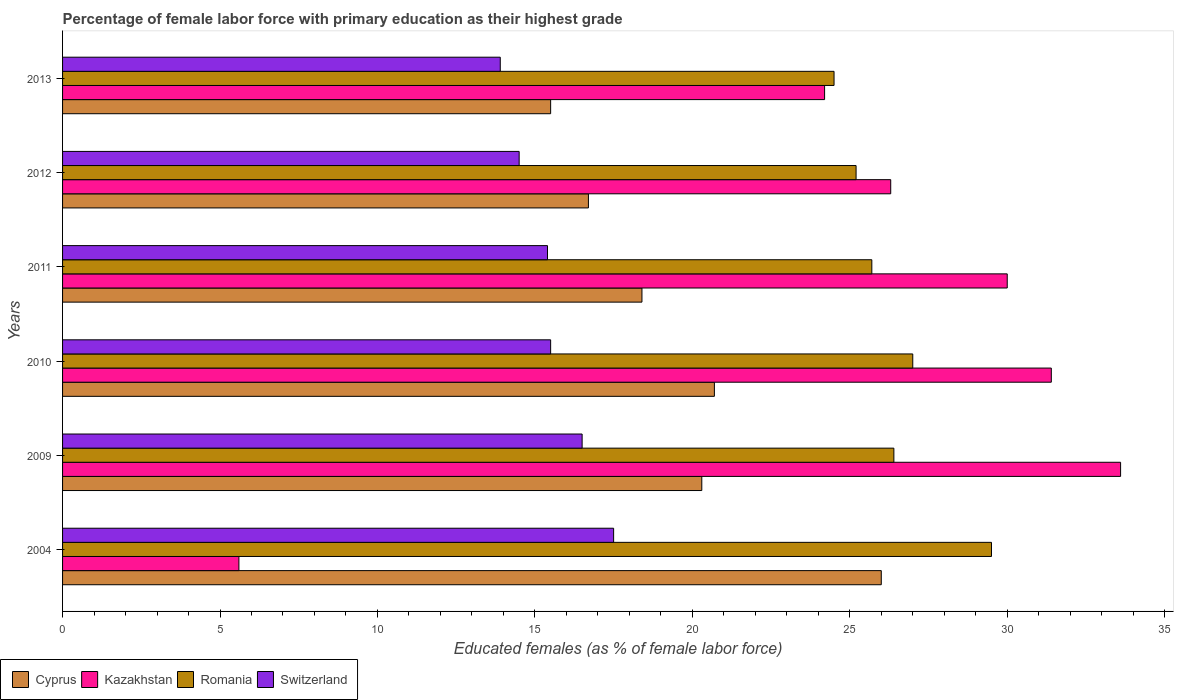How many different coloured bars are there?
Offer a terse response. 4. Are the number of bars on each tick of the Y-axis equal?
Your answer should be compact. Yes. How many bars are there on the 6th tick from the top?
Offer a terse response. 4. How many bars are there on the 5th tick from the bottom?
Offer a terse response. 4. What is the label of the 3rd group of bars from the top?
Provide a succinct answer. 2011. What is the percentage of female labor force with primary education in Romania in 2013?
Your response must be concise. 24.5. Across all years, what is the maximum percentage of female labor force with primary education in Cyprus?
Your response must be concise. 26. Across all years, what is the minimum percentage of female labor force with primary education in Switzerland?
Keep it short and to the point. 13.9. In which year was the percentage of female labor force with primary education in Cyprus maximum?
Your answer should be very brief. 2004. In which year was the percentage of female labor force with primary education in Romania minimum?
Make the answer very short. 2013. What is the total percentage of female labor force with primary education in Romania in the graph?
Give a very brief answer. 158.3. What is the difference between the percentage of female labor force with primary education in Romania in 2009 and that in 2010?
Ensure brevity in your answer.  -0.6. What is the difference between the percentage of female labor force with primary education in Switzerland in 2010 and the percentage of female labor force with primary education in Romania in 2012?
Offer a terse response. -9.7. What is the average percentage of female labor force with primary education in Romania per year?
Your answer should be compact. 26.38. In the year 2013, what is the difference between the percentage of female labor force with primary education in Cyprus and percentage of female labor force with primary education in Kazakhstan?
Offer a terse response. -8.7. What is the ratio of the percentage of female labor force with primary education in Romania in 2004 to that in 2010?
Ensure brevity in your answer.  1.09. Is the percentage of female labor force with primary education in Cyprus in 2011 less than that in 2013?
Ensure brevity in your answer.  No. Is the difference between the percentage of female labor force with primary education in Cyprus in 2009 and 2012 greater than the difference between the percentage of female labor force with primary education in Kazakhstan in 2009 and 2012?
Your answer should be compact. No. Is the sum of the percentage of female labor force with primary education in Switzerland in 2011 and 2012 greater than the maximum percentage of female labor force with primary education in Kazakhstan across all years?
Your response must be concise. No. Is it the case that in every year, the sum of the percentage of female labor force with primary education in Romania and percentage of female labor force with primary education in Kazakhstan is greater than the sum of percentage of female labor force with primary education in Cyprus and percentage of female labor force with primary education in Switzerland?
Offer a very short reply. No. What does the 1st bar from the top in 2009 represents?
Provide a succinct answer. Switzerland. What does the 3rd bar from the bottom in 2011 represents?
Keep it short and to the point. Romania. Are all the bars in the graph horizontal?
Your response must be concise. Yes. How many years are there in the graph?
Your response must be concise. 6. Are the values on the major ticks of X-axis written in scientific E-notation?
Make the answer very short. No. Does the graph contain any zero values?
Keep it short and to the point. No. Does the graph contain grids?
Your answer should be compact. No. Where does the legend appear in the graph?
Keep it short and to the point. Bottom left. What is the title of the graph?
Provide a short and direct response. Percentage of female labor force with primary education as their highest grade. What is the label or title of the X-axis?
Provide a short and direct response. Educated females (as % of female labor force). What is the label or title of the Y-axis?
Give a very brief answer. Years. What is the Educated females (as % of female labor force) in Cyprus in 2004?
Provide a succinct answer. 26. What is the Educated females (as % of female labor force) in Kazakhstan in 2004?
Offer a very short reply. 5.6. What is the Educated females (as % of female labor force) of Romania in 2004?
Provide a succinct answer. 29.5. What is the Educated females (as % of female labor force) of Cyprus in 2009?
Your response must be concise. 20.3. What is the Educated females (as % of female labor force) of Kazakhstan in 2009?
Offer a terse response. 33.6. What is the Educated females (as % of female labor force) in Romania in 2009?
Your response must be concise. 26.4. What is the Educated females (as % of female labor force) of Switzerland in 2009?
Offer a very short reply. 16.5. What is the Educated females (as % of female labor force) of Cyprus in 2010?
Offer a terse response. 20.7. What is the Educated females (as % of female labor force) in Kazakhstan in 2010?
Make the answer very short. 31.4. What is the Educated females (as % of female labor force) of Switzerland in 2010?
Keep it short and to the point. 15.5. What is the Educated females (as % of female labor force) in Cyprus in 2011?
Offer a terse response. 18.4. What is the Educated females (as % of female labor force) in Romania in 2011?
Offer a very short reply. 25.7. What is the Educated females (as % of female labor force) of Switzerland in 2011?
Ensure brevity in your answer.  15.4. What is the Educated females (as % of female labor force) in Cyprus in 2012?
Give a very brief answer. 16.7. What is the Educated females (as % of female labor force) of Kazakhstan in 2012?
Your response must be concise. 26.3. What is the Educated females (as % of female labor force) of Romania in 2012?
Give a very brief answer. 25.2. What is the Educated females (as % of female labor force) in Kazakhstan in 2013?
Your answer should be very brief. 24.2. What is the Educated females (as % of female labor force) in Romania in 2013?
Your answer should be compact. 24.5. What is the Educated females (as % of female labor force) in Switzerland in 2013?
Your answer should be compact. 13.9. Across all years, what is the maximum Educated females (as % of female labor force) in Cyprus?
Give a very brief answer. 26. Across all years, what is the maximum Educated females (as % of female labor force) in Kazakhstan?
Keep it short and to the point. 33.6. Across all years, what is the maximum Educated females (as % of female labor force) of Romania?
Provide a succinct answer. 29.5. Across all years, what is the maximum Educated females (as % of female labor force) of Switzerland?
Make the answer very short. 17.5. Across all years, what is the minimum Educated females (as % of female labor force) in Kazakhstan?
Your answer should be very brief. 5.6. Across all years, what is the minimum Educated females (as % of female labor force) of Romania?
Offer a very short reply. 24.5. Across all years, what is the minimum Educated females (as % of female labor force) in Switzerland?
Keep it short and to the point. 13.9. What is the total Educated females (as % of female labor force) of Cyprus in the graph?
Ensure brevity in your answer.  117.6. What is the total Educated females (as % of female labor force) of Kazakhstan in the graph?
Keep it short and to the point. 151.1. What is the total Educated females (as % of female labor force) in Romania in the graph?
Keep it short and to the point. 158.3. What is the total Educated females (as % of female labor force) of Switzerland in the graph?
Keep it short and to the point. 93.3. What is the difference between the Educated females (as % of female labor force) of Cyprus in 2004 and that in 2009?
Offer a terse response. 5.7. What is the difference between the Educated females (as % of female labor force) of Kazakhstan in 2004 and that in 2009?
Provide a short and direct response. -28. What is the difference between the Educated females (as % of female labor force) of Cyprus in 2004 and that in 2010?
Offer a terse response. 5.3. What is the difference between the Educated females (as % of female labor force) in Kazakhstan in 2004 and that in 2010?
Give a very brief answer. -25.8. What is the difference between the Educated females (as % of female labor force) in Switzerland in 2004 and that in 2010?
Make the answer very short. 2. What is the difference between the Educated females (as % of female labor force) of Kazakhstan in 2004 and that in 2011?
Your response must be concise. -24.4. What is the difference between the Educated females (as % of female labor force) in Kazakhstan in 2004 and that in 2012?
Keep it short and to the point. -20.7. What is the difference between the Educated females (as % of female labor force) in Switzerland in 2004 and that in 2012?
Keep it short and to the point. 3. What is the difference between the Educated females (as % of female labor force) in Cyprus in 2004 and that in 2013?
Make the answer very short. 10.5. What is the difference between the Educated females (as % of female labor force) in Kazakhstan in 2004 and that in 2013?
Offer a very short reply. -18.6. What is the difference between the Educated females (as % of female labor force) in Cyprus in 2009 and that in 2010?
Your answer should be compact. -0.4. What is the difference between the Educated females (as % of female labor force) in Romania in 2009 and that in 2010?
Ensure brevity in your answer.  -0.6. What is the difference between the Educated females (as % of female labor force) of Cyprus in 2009 and that in 2011?
Ensure brevity in your answer.  1.9. What is the difference between the Educated females (as % of female labor force) in Kazakhstan in 2009 and that in 2011?
Your answer should be compact. 3.6. What is the difference between the Educated females (as % of female labor force) in Romania in 2009 and that in 2011?
Keep it short and to the point. 0.7. What is the difference between the Educated females (as % of female labor force) of Cyprus in 2009 and that in 2012?
Provide a succinct answer. 3.6. What is the difference between the Educated females (as % of female labor force) in Romania in 2009 and that in 2012?
Your answer should be very brief. 1.2. What is the difference between the Educated females (as % of female labor force) in Romania in 2009 and that in 2013?
Your answer should be very brief. 1.9. What is the difference between the Educated females (as % of female labor force) in Switzerland in 2009 and that in 2013?
Provide a short and direct response. 2.6. What is the difference between the Educated females (as % of female labor force) of Cyprus in 2010 and that in 2011?
Your response must be concise. 2.3. What is the difference between the Educated females (as % of female labor force) of Kazakhstan in 2010 and that in 2011?
Your response must be concise. 1.4. What is the difference between the Educated females (as % of female labor force) of Romania in 2010 and that in 2012?
Your answer should be compact. 1.8. What is the difference between the Educated females (as % of female labor force) of Switzerland in 2010 and that in 2012?
Keep it short and to the point. 1. What is the difference between the Educated females (as % of female labor force) in Cyprus in 2010 and that in 2013?
Give a very brief answer. 5.2. What is the difference between the Educated females (as % of female labor force) of Romania in 2010 and that in 2013?
Provide a short and direct response. 2.5. What is the difference between the Educated females (as % of female labor force) in Switzerland in 2010 and that in 2013?
Your response must be concise. 1.6. What is the difference between the Educated females (as % of female labor force) in Cyprus in 2011 and that in 2012?
Your answer should be compact. 1.7. What is the difference between the Educated females (as % of female labor force) of Kazakhstan in 2011 and that in 2012?
Your response must be concise. 3.7. What is the difference between the Educated females (as % of female labor force) of Cyprus in 2011 and that in 2013?
Offer a very short reply. 2.9. What is the difference between the Educated females (as % of female labor force) in Cyprus in 2004 and the Educated females (as % of female labor force) in Kazakhstan in 2009?
Provide a short and direct response. -7.6. What is the difference between the Educated females (as % of female labor force) in Cyprus in 2004 and the Educated females (as % of female labor force) in Romania in 2009?
Provide a succinct answer. -0.4. What is the difference between the Educated females (as % of female labor force) of Kazakhstan in 2004 and the Educated females (as % of female labor force) of Romania in 2009?
Your response must be concise. -20.8. What is the difference between the Educated females (as % of female labor force) in Romania in 2004 and the Educated females (as % of female labor force) in Switzerland in 2009?
Provide a short and direct response. 13. What is the difference between the Educated females (as % of female labor force) of Cyprus in 2004 and the Educated females (as % of female labor force) of Romania in 2010?
Make the answer very short. -1. What is the difference between the Educated females (as % of female labor force) in Kazakhstan in 2004 and the Educated females (as % of female labor force) in Romania in 2010?
Your response must be concise. -21.4. What is the difference between the Educated females (as % of female labor force) in Romania in 2004 and the Educated females (as % of female labor force) in Switzerland in 2010?
Offer a very short reply. 14. What is the difference between the Educated females (as % of female labor force) of Cyprus in 2004 and the Educated females (as % of female labor force) of Kazakhstan in 2011?
Offer a very short reply. -4. What is the difference between the Educated females (as % of female labor force) in Cyprus in 2004 and the Educated females (as % of female labor force) in Switzerland in 2011?
Your answer should be very brief. 10.6. What is the difference between the Educated females (as % of female labor force) of Kazakhstan in 2004 and the Educated females (as % of female labor force) of Romania in 2011?
Your answer should be compact. -20.1. What is the difference between the Educated females (as % of female labor force) of Kazakhstan in 2004 and the Educated females (as % of female labor force) of Switzerland in 2011?
Ensure brevity in your answer.  -9.8. What is the difference between the Educated females (as % of female labor force) in Romania in 2004 and the Educated females (as % of female labor force) in Switzerland in 2011?
Offer a very short reply. 14.1. What is the difference between the Educated females (as % of female labor force) of Kazakhstan in 2004 and the Educated females (as % of female labor force) of Romania in 2012?
Your response must be concise. -19.6. What is the difference between the Educated females (as % of female labor force) in Romania in 2004 and the Educated females (as % of female labor force) in Switzerland in 2012?
Keep it short and to the point. 15. What is the difference between the Educated females (as % of female labor force) of Cyprus in 2004 and the Educated females (as % of female labor force) of Switzerland in 2013?
Offer a very short reply. 12.1. What is the difference between the Educated females (as % of female labor force) of Kazakhstan in 2004 and the Educated females (as % of female labor force) of Romania in 2013?
Provide a short and direct response. -18.9. What is the difference between the Educated females (as % of female labor force) of Kazakhstan in 2004 and the Educated females (as % of female labor force) of Switzerland in 2013?
Provide a short and direct response. -8.3. What is the difference between the Educated females (as % of female labor force) of Cyprus in 2009 and the Educated females (as % of female labor force) of Switzerland in 2010?
Your answer should be very brief. 4.8. What is the difference between the Educated females (as % of female labor force) of Kazakhstan in 2009 and the Educated females (as % of female labor force) of Switzerland in 2010?
Your answer should be very brief. 18.1. What is the difference between the Educated females (as % of female labor force) in Cyprus in 2009 and the Educated females (as % of female labor force) in Kazakhstan in 2011?
Offer a terse response. -9.7. What is the difference between the Educated females (as % of female labor force) in Cyprus in 2009 and the Educated females (as % of female labor force) in Romania in 2011?
Offer a very short reply. -5.4. What is the difference between the Educated females (as % of female labor force) of Cyprus in 2009 and the Educated females (as % of female labor force) of Switzerland in 2011?
Your answer should be compact. 4.9. What is the difference between the Educated females (as % of female labor force) in Kazakhstan in 2009 and the Educated females (as % of female labor force) in Romania in 2011?
Offer a very short reply. 7.9. What is the difference between the Educated females (as % of female labor force) of Kazakhstan in 2009 and the Educated females (as % of female labor force) of Switzerland in 2011?
Your answer should be very brief. 18.2. What is the difference between the Educated females (as % of female labor force) of Kazakhstan in 2009 and the Educated females (as % of female labor force) of Romania in 2012?
Ensure brevity in your answer.  8.4. What is the difference between the Educated females (as % of female labor force) in Kazakhstan in 2009 and the Educated females (as % of female labor force) in Switzerland in 2012?
Give a very brief answer. 19.1. What is the difference between the Educated females (as % of female labor force) in Romania in 2009 and the Educated females (as % of female labor force) in Switzerland in 2012?
Your answer should be compact. 11.9. What is the difference between the Educated females (as % of female labor force) in Cyprus in 2009 and the Educated females (as % of female labor force) in Kazakhstan in 2013?
Make the answer very short. -3.9. What is the difference between the Educated females (as % of female labor force) of Cyprus in 2009 and the Educated females (as % of female labor force) of Romania in 2013?
Provide a succinct answer. -4.2. What is the difference between the Educated females (as % of female labor force) of Kazakhstan in 2009 and the Educated females (as % of female labor force) of Switzerland in 2013?
Your response must be concise. 19.7. What is the difference between the Educated females (as % of female labor force) in Romania in 2009 and the Educated females (as % of female labor force) in Switzerland in 2013?
Provide a short and direct response. 12.5. What is the difference between the Educated females (as % of female labor force) of Cyprus in 2010 and the Educated females (as % of female labor force) of Switzerland in 2011?
Provide a succinct answer. 5.3. What is the difference between the Educated females (as % of female labor force) of Kazakhstan in 2010 and the Educated females (as % of female labor force) of Switzerland in 2011?
Give a very brief answer. 16. What is the difference between the Educated females (as % of female labor force) in Cyprus in 2010 and the Educated females (as % of female labor force) in Kazakhstan in 2012?
Ensure brevity in your answer.  -5.6. What is the difference between the Educated females (as % of female labor force) of Cyprus in 2010 and the Educated females (as % of female labor force) of Romania in 2012?
Provide a short and direct response. -4.5. What is the difference between the Educated females (as % of female labor force) of Kazakhstan in 2010 and the Educated females (as % of female labor force) of Romania in 2012?
Give a very brief answer. 6.2. What is the difference between the Educated females (as % of female labor force) in Kazakhstan in 2010 and the Educated females (as % of female labor force) in Switzerland in 2012?
Your answer should be compact. 16.9. What is the difference between the Educated females (as % of female labor force) of Cyprus in 2010 and the Educated females (as % of female labor force) of Kazakhstan in 2013?
Keep it short and to the point. -3.5. What is the difference between the Educated females (as % of female labor force) in Cyprus in 2010 and the Educated females (as % of female labor force) in Switzerland in 2013?
Provide a short and direct response. 6.8. What is the difference between the Educated females (as % of female labor force) in Kazakhstan in 2010 and the Educated females (as % of female labor force) in Switzerland in 2013?
Offer a terse response. 17.5. What is the difference between the Educated females (as % of female labor force) in Romania in 2010 and the Educated females (as % of female labor force) in Switzerland in 2013?
Keep it short and to the point. 13.1. What is the difference between the Educated females (as % of female labor force) of Cyprus in 2011 and the Educated females (as % of female labor force) of Switzerland in 2012?
Your answer should be very brief. 3.9. What is the difference between the Educated females (as % of female labor force) of Kazakhstan in 2011 and the Educated females (as % of female labor force) of Romania in 2012?
Your answer should be compact. 4.8. What is the difference between the Educated females (as % of female labor force) in Cyprus in 2011 and the Educated females (as % of female labor force) in Kazakhstan in 2013?
Your answer should be very brief. -5.8. What is the difference between the Educated females (as % of female labor force) in Cyprus in 2011 and the Educated females (as % of female labor force) in Romania in 2013?
Ensure brevity in your answer.  -6.1. What is the difference between the Educated females (as % of female labor force) of Cyprus in 2011 and the Educated females (as % of female labor force) of Switzerland in 2013?
Give a very brief answer. 4.5. What is the difference between the Educated females (as % of female labor force) in Kazakhstan in 2011 and the Educated females (as % of female labor force) in Romania in 2013?
Offer a terse response. 5.5. What is the difference between the Educated females (as % of female labor force) in Kazakhstan in 2011 and the Educated females (as % of female labor force) in Switzerland in 2013?
Your answer should be very brief. 16.1. What is the difference between the Educated females (as % of female labor force) of Cyprus in 2012 and the Educated females (as % of female labor force) of Kazakhstan in 2013?
Make the answer very short. -7.5. What is the difference between the Educated females (as % of female labor force) in Cyprus in 2012 and the Educated females (as % of female labor force) in Switzerland in 2013?
Provide a short and direct response. 2.8. What is the difference between the Educated females (as % of female labor force) in Kazakhstan in 2012 and the Educated females (as % of female labor force) in Switzerland in 2013?
Make the answer very short. 12.4. What is the average Educated females (as % of female labor force) of Cyprus per year?
Your answer should be compact. 19.6. What is the average Educated females (as % of female labor force) of Kazakhstan per year?
Your answer should be very brief. 25.18. What is the average Educated females (as % of female labor force) of Romania per year?
Offer a terse response. 26.38. What is the average Educated females (as % of female labor force) in Switzerland per year?
Keep it short and to the point. 15.55. In the year 2004, what is the difference between the Educated females (as % of female labor force) of Cyprus and Educated females (as % of female labor force) of Kazakhstan?
Keep it short and to the point. 20.4. In the year 2004, what is the difference between the Educated females (as % of female labor force) of Cyprus and Educated females (as % of female labor force) of Romania?
Ensure brevity in your answer.  -3.5. In the year 2004, what is the difference between the Educated females (as % of female labor force) of Kazakhstan and Educated females (as % of female labor force) of Romania?
Ensure brevity in your answer.  -23.9. In the year 2004, what is the difference between the Educated females (as % of female labor force) in Kazakhstan and Educated females (as % of female labor force) in Switzerland?
Offer a terse response. -11.9. In the year 2004, what is the difference between the Educated females (as % of female labor force) of Romania and Educated females (as % of female labor force) of Switzerland?
Your answer should be very brief. 12. In the year 2009, what is the difference between the Educated females (as % of female labor force) of Cyprus and Educated females (as % of female labor force) of Kazakhstan?
Make the answer very short. -13.3. In the year 2009, what is the difference between the Educated females (as % of female labor force) in Cyprus and Educated females (as % of female labor force) in Romania?
Offer a very short reply. -6.1. In the year 2009, what is the difference between the Educated females (as % of female labor force) in Cyprus and Educated females (as % of female labor force) in Switzerland?
Your answer should be very brief. 3.8. In the year 2009, what is the difference between the Educated females (as % of female labor force) in Kazakhstan and Educated females (as % of female labor force) in Romania?
Provide a succinct answer. 7.2. In the year 2009, what is the difference between the Educated females (as % of female labor force) in Kazakhstan and Educated females (as % of female labor force) in Switzerland?
Give a very brief answer. 17.1. In the year 2010, what is the difference between the Educated females (as % of female labor force) of Kazakhstan and Educated females (as % of female labor force) of Romania?
Make the answer very short. 4.4. In the year 2011, what is the difference between the Educated females (as % of female labor force) of Cyprus and Educated females (as % of female labor force) of Kazakhstan?
Your answer should be very brief. -11.6. In the year 2011, what is the difference between the Educated females (as % of female labor force) in Cyprus and Educated females (as % of female labor force) in Romania?
Make the answer very short. -7.3. In the year 2011, what is the difference between the Educated females (as % of female labor force) in Cyprus and Educated females (as % of female labor force) in Switzerland?
Offer a terse response. 3. In the year 2011, what is the difference between the Educated females (as % of female labor force) in Kazakhstan and Educated females (as % of female labor force) in Switzerland?
Provide a short and direct response. 14.6. In the year 2011, what is the difference between the Educated females (as % of female labor force) of Romania and Educated females (as % of female labor force) of Switzerland?
Your response must be concise. 10.3. In the year 2012, what is the difference between the Educated females (as % of female labor force) of Cyprus and Educated females (as % of female labor force) of Kazakhstan?
Give a very brief answer. -9.6. In the year 2012, what is the difference between the Educated females (as % of female labor force) in Kazakhstan and Educated females (as % of female labor force) in Romania?
Provide a short and direct response. 1.1. In the year 2012, what is the difference between the Educated females (as % of female labor force) in Kazakhstan and Educated females (as % of female labor force) in Switzerland?
Provide a short and direct response. 11.8. In the year 2012, what is the difference between the Educated females (as % of female labor force) of Romania and Educated females (as % of female labor force) of Switzerland?
Ensure brevity in your answer.  10.7. In the year 2013, what is the difference between the Educated females (as % of female labor force) in Cyprus and Educated females (as % of female labor force) in Kazakhstan?
Provide a succinct answer. -8.7. In the year 2013, what is the difference between the Educated females (as % of female labor force) of Kazakhstan and Educated females (as % of female labor force) of Romania?
Make the answer very short. -0.3. In the year 2013, what is the difference between the Educated females (as % of female labor force) in Kazakhstan and Educated females (as % of female labor force) in Switzerland?
Offer a very short reply. 10.3. In the year 2013, what is the difference between the Educated females (as % of female labor force) of Romania and Educated females (as % of female labor force) of Switzerland?
Your response must be concise. 10.6. What is the ratio of the Educated females (as % of female labor force) of Cyprus in 2004 to that in 2009?
Keep it short and to the point. 1.28. What is the ratio of the Educated females (as % of female labor force) of Romania in 2004 to that in 2009?
Your answer should be compact. 1.12. What is the ratio of the Educated females (as % of female labor force) in Switzerland in 2004 to that in 2009?
Ensure brevity in your answer.  1.06. What is the ratio of the Educated females (as % of female labor force) in Cyprus in 2004 to that in 2010?
Offer a very short reply. 1.26. What is the ratio of the Educated females (as % of female labor force) in Kazakhstan in 2004 to that in 2010?
Your response must be concise. 0.18. What is the ratio of the Educated females (as % of female labor force) in Romania in 2004 to that in 2010?
Give a very brief answer. 1.09. What is the ratio of the Educated females (as % of female labor force) in Switzerland in 2004 to that in 2010?
Make the answer very short. 1.13. What is the ratio of the Educated females (as % of female labor force) of Cyprus in 2004 to that in 2011?
Ensure brevity in your answer.  1.41. What is the ratio of the Educated females (as % of female labor force) of Kazakhstan in 2004 to that in 2011?
Make the answer very short. 0.19. What is the ratio of the Educated females (as % of female labor force) of Romania in 2004 to that in 2011?
Your response must be concise. 1.15. What is the ratio of the Educated females (as % of female labor force) in Switzerland in 2004 to that in 2011?
Keep it short and to the point. 1.14. What is the ratio of the Educated females (as % of female labor force) in Cyprus in 2004 to that in 2012?
Provide a succinct answer. 1.56. What is the ratio of the Educated females (as % of female labor force) in Kazakhstan in 2004 to that in 2012?
Ensure brevity in your answer.  0.21. What is the ratio of the Educated females (as % of female labor force) in Romania in 2004 to that in 2012?
Provide a succinct answer. 1.17. What is the ratio of the Educated females (as % of female labor force) in Switzerland in 2004 to that in 2012?
Your answer should be very brief. 1.21. What is the ratio of the Educated females (as % of female labor force) of Cyprus in 2004 to that in 2013?
Provide a short and direct response. 1.68. What is the ratio of the Educated females (as % of female labor force) in Kazakhstan in 2004 to that in 2013?
Provide a succinct answer. 0.23. What is the ratio of the Educated females (as % of female labor force) of Romania in 2004 to that in 2013?
Your response must be concise. 1.2. What is the ratio of the Educated females (as % of female labor force) of Switzerland in 2004 to that in 2013?
Offer a very short reply. 1.26. What is the ratio of the Educated females (as % of female labor force) in Cyprus in 2009 to that in 2010?
Your response must be concise. 0.98. What is the ratio of the Educated females (as % of female labor force) of Kazakhstan in 2009 to that in 2010?
Your answer should be compact. 1.07. What is the ratio of the Educated females (as % of female labor force) in Romania in 2009 to that in 2010?
Your answer should be compact. 0.98. What is the ratio of the Educated females (as % of female labor force) in Switzerland in 2009 to that in 2010?
Make the answer very short. 1.06. What is the ratio of the Educated females (as % of female labor force) of Cyprus in 2009 to that in 2011?
Make the answer very short. 1.1. What is the ratio of the Educated females (as % of female labor force) of Kazakhstan in 2009 to that in 2011?
Give a very brief answer. 1.12. What is the ratio of the Educated females (as % of female labor force) in Romania in 2009 to that in 2011?
Your answer should be very brief. 1.03. What is the ratio of the Educated females (as % of female labor force) of Switzerland in 2009 to that in 2011?
Provide a succinct answer. 1.07. What is the ratio of the Educated females (as % of female labor force) of Cyprus in 2009 to that in 2012?
Your response must be concise. 1.22. What is the ratio of the Educated females (as % of female labor force) in Kazakhstan in 2009 to that in 2012?
Your answer should be compact. 1.28. What is the ratio of the Educated females (as % of female labor force) of Romania in 2009 to that in 2012?
Offer a very short reply. 1.05. What is the ratio of the Educated females (as % of female labor force) of Switzerland in 2009 to that in 2012?
Your answer should be very brief. 1.14. What is the ratio of the Educated females (as % of female labor force) in Cyprus in 2009 to that in 2013?
Your answer should be compact. 1.31. What is the ratio of the Educated females (as % of female labor force) of Kazakhstan in 2009 to that in 2013?
Ensure brevity in your answer.  1.39. What is the ratio of the Educated females (as % of female labor force) in Romania in 2009 to that in 2013?
Provide a short and direct response. 1.08. What is the ratio of the Educated females (as % of female labor force) of Switzerland in 2009 to that in 2013?
Provide a short and direct response. 1.19. What is the ratio of the Educated females (as % of female labor force) in Kazakhstan in 2010 to that in 2011?
Make the answer very short. 1.05. What is the ratio of the Educated females (as % of female labor force) of Romania in 2010 to that in 2011?
Provide a succinct answer. 1.05. What is the ratio of the Educated females (as % of female labor force) of Switzerland in 2010 to that in 2011?
Offer a terse response. 1.01. What is the ratio of the Educated females (as % of female labor force) in Cyprus in 2010 to that in 2012?
Provide a succinct answer. 1.24. What is the ratio of the Educated females (as % of female labor force) in Kazakhstan in 2010 to that in 2012?
Your answer should be compact. 1.19. What is the ratio of the Educated females (as % of female labor force) in Romania in 2010 to that in 2012?
Offer a very short reply. 1.07. What is the ratio of the Educated females (as % of female labor force) in Switzerland in 2010 to that in 2012?
Offer a terse response. 1.07. What is the ratio of the Educated females (as % of female labor force) in Cyprus in 2010 to that in 2013?
Your response must be concise. 1.34. What is the ratio of the Educated females (as % of female labor force) of Kazakhstan in 2010 to that in 2013?
Your answer should be compact. 1.3. What is the ratio of the Educated females (as % of female labor force) in Romania in 2010 to that in 2013?
Your response must be concise. 1.1. What is the ratio of the Educated females (as % of female labor force) in Switzerland in 2010 to that in 2013?
Give a very brief answer. 1.12. What is the ratio of the Educated females (as % of female labor force) in Cyprus in 2011 to that in 2012?
Offer a terse response. 1.1. What is the ratio of the Educated females (as % of female labor force) of Kazakhstan in 2011 to that in 2012?
Provide a succinct answer. 1.14. What is the ratio of the Educated females (as % of female labor force) in Romania in 2011 to that in 2012?
Offer a very short reply. 1.02. What is the ratio of the Educated females (as % of female labor force) of Switzerland in 2011 to that in 2012?
Your answer should be very brief. 1.06. What is the ratio of the Educated females (as % of female labor force) in Cyprus in 2011 to that in 2013?
Give a very brief answer. 1.19. What is the ratio of the Educated females (as % of female labor force) of Kazakhstan in 2011 to that in 2013?
Give a very brief answer. 1.24. What is the ratio of the Educated females (as % of female labor force) of Romania in 2011 to that in 2013?
Your response must be concise. 1.05. What is the ratio of the Educated females (as % of female labor force) in Switzerland in 2011 to that in 2013?
Provide a short and direct response. 1.11. What is the ratio of the Educated females (as % of female labor force) of Cyprus in 2012 to that in 2013?
Your answer should be very brief. 1.08. What is the ratio of the Educated females (as % of female labor force) of Kazakhstan in 2012 to that in 2013?
Keep it short and to the point. 1.09. What is the ratio of the Educated females (as % of female labor force) in Romania in 2012 to that in 2013?
Your answer should be very brief. 1.03. What is the ratio of the Educated females (as % of female labor force) in Switzerland in 2012 to that in 2013?
Provide a succinct answer. 1.04. What is the difference between the highest and the second highest Educated females (as % of female labor force) of Cyprus?
Offer a very short reply. 5.3. What is the difference between the highest and the lowest Educated females (as % of female labor force) in Cyprus?
Provide a succinct answer. 10.5. What is the difference between the highest and the lowest Educated females (as % of female labor force) of Romania?
Provide a short and direct response. 5. What is the difference between the highest and the lowest Educated females (as % of female labor force) in Switzerland?
Your response must be concise. 3.6. 